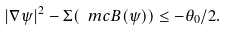Convert formula to latex. <formula><loc_0><loc_0><loc_500><loc_500>| \nabla \psi | ^ { 2 } - \Sigma ( \ m c B ( \psi ) ) \leq - \theta _ { 0 } / 2 .</formula> 